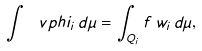Convert formula to latex. <formula><loc_0><loc_0><loc_500><loc_500>\int \ v p h i _ { i } \, d \mu = \int _ { Q _ { i } } f \, w _ { i } \, d \mu ,</formula> 